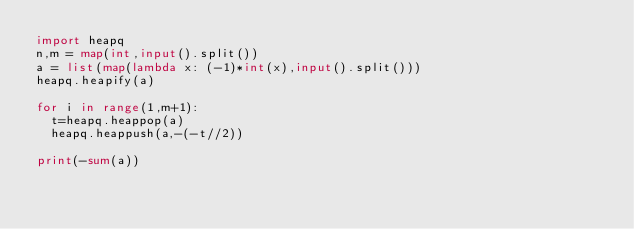Convert code to text. <code><loc_0><loc_0><loc_500><loc_500><_Python_>import heapq
n,m = map(int,input().split())
a = list(map(lambda x: (-1)*int(x),input().split()))
heapq.heapify(a)

for i in range(1,m+1):
  t=heapq.heappop(a)
  heapq.heappush(a,-(-t//2))

print(-sum(a))</code> 